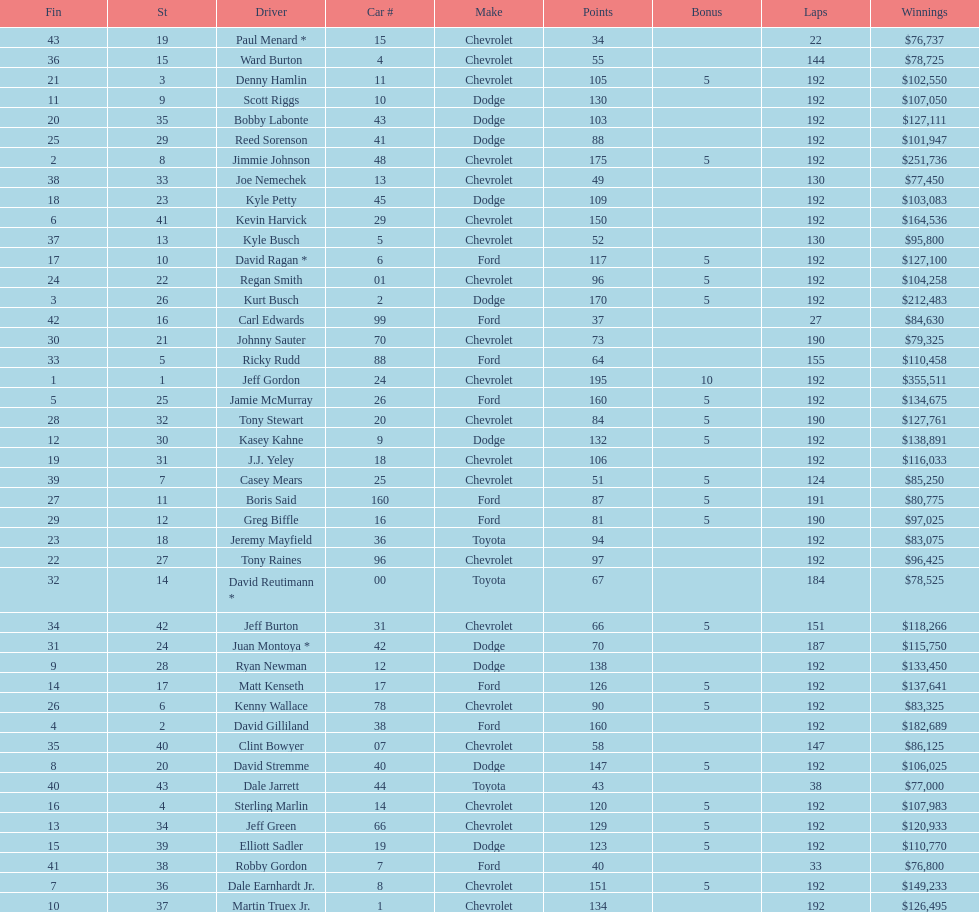How many drivers earned 5 bonus each in the race? 19. 